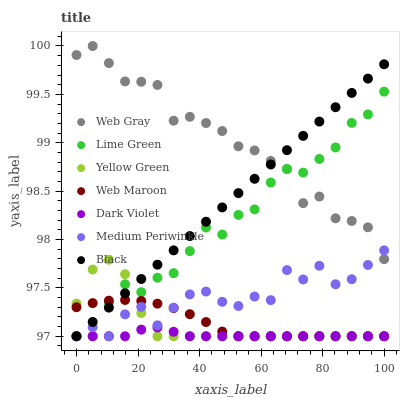Does Dark Violet have the minimum area under the curve?
Answer yes or no. Yes. Does Web Gray have the maximum area under the curve?
Answer yes or no. Yes. Does Yellow Green have the minimum area under the curve?
Answer yes or no. No. Does Yellow Green have the maximum area under the curve?
Answer yes or no. No. Is Black the smoothest?
Answer yes or no. Yes. Is Medium Periwinkle the roughest?
Answer yes or no. Yes. Is Yellow Green the smoothest?
Answer yes or no. No. Is Yellow Green the roughest?
Answer yes or no. No. Does Yellow Green have the lowest value?
Answer yes or no. Yes. Does Web Gray have the highest value?
Answer yes or no. Yes. Does Yellow Green have the highest value?
Answer yes or no. No. Is Yellow Green less than Web Gray?
Answer yes or no. Yes. Is Web Gray greater than Dark Violet?
Answer yes or no. Yes. Does Yellow Green intersect Black?
Answer yes or no. Yes. Is Yellow Green less than Black?
Answer yes or no. No. Is Yellow Green greater than Black?
Answer yes or no. No. Does Yellow Green intersect Web Gray?
Answer yes or no. No. 